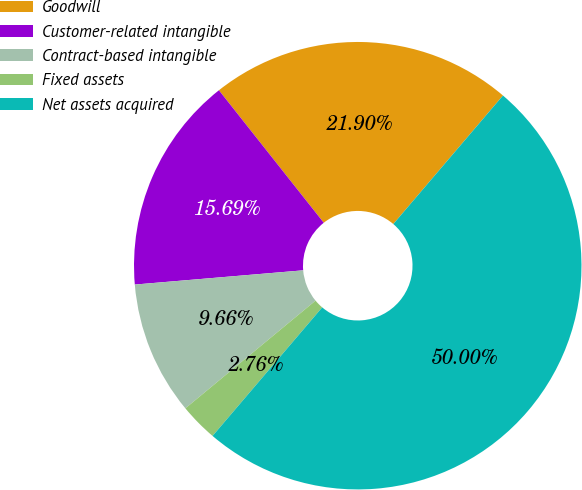Convert chart to OTSL. <chart><loc_0><loc_0><loc_500><loc_500><pie_chart><fcel>Goodwill<fcel>Customer-related intangible<fcel>Contract-based intangible<fcel>Fixed assets<fcel>Net assets acquired<nl><fcel>21.9%<fcel>15.69%<fcel>9.66%<fcel>2.76%<fcel>50.0%<nl></chart> 